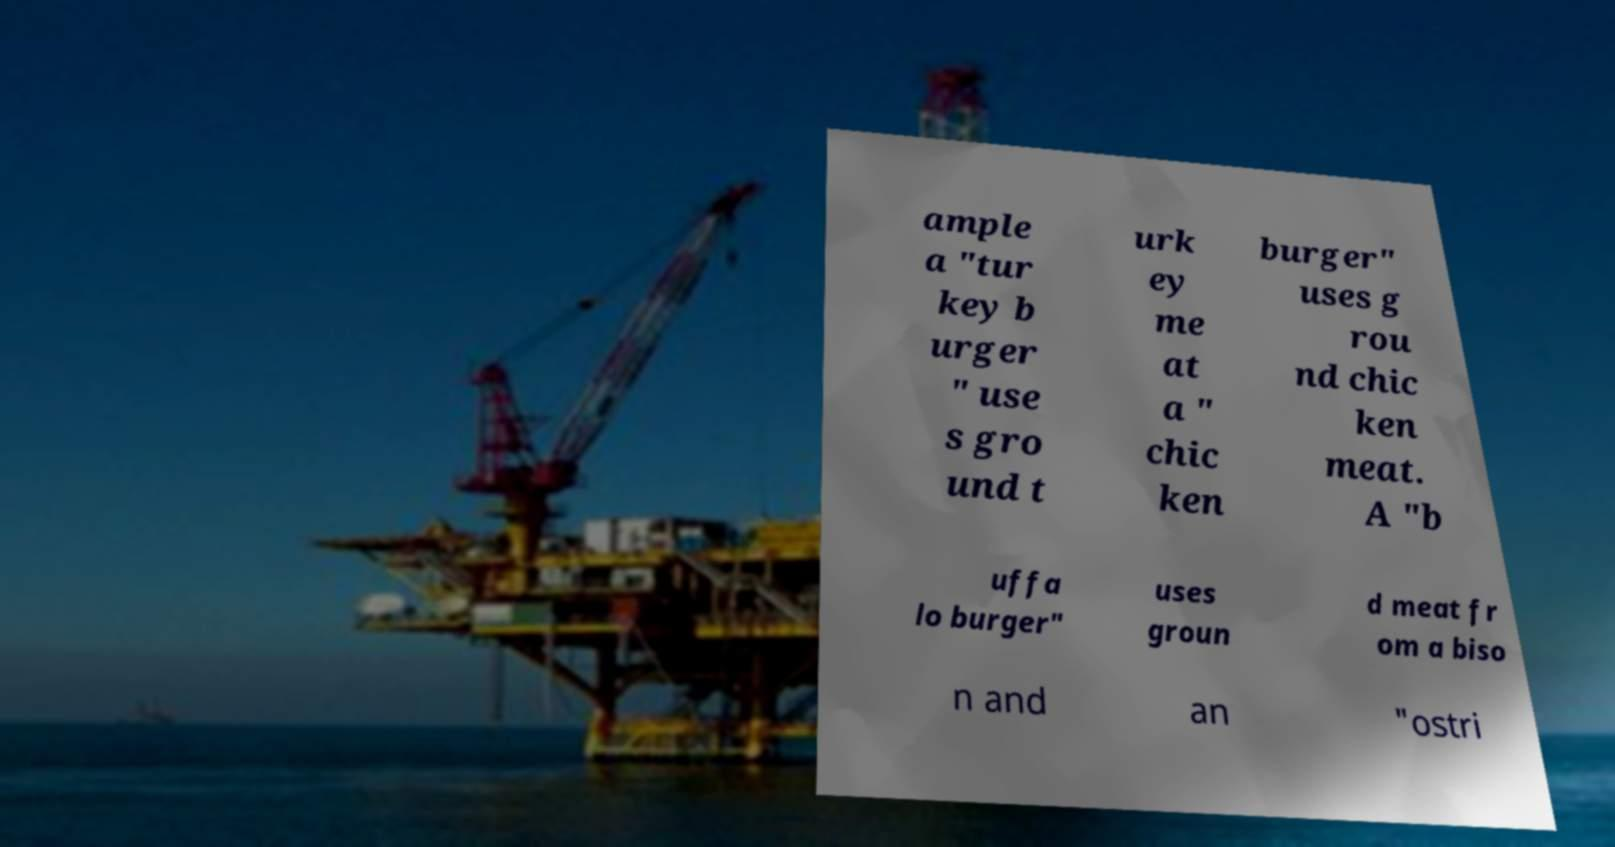Please read and relay the text visible in this image. What does it say? ample a "tur key b urger " use s gro und t urk ey me at a " chic ken burger" uses g rou nd chic ken meat. A "b uffa lo burger" uses groun d meat fr om a biso n and an "ostri 